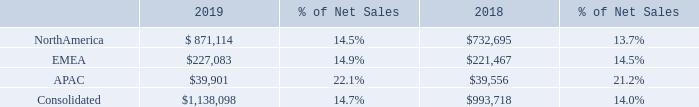Gross Profit. Gross profit increased 15%, or $144.4 million, in 2019 compared to 2018, with gross margin increasing approximately 70 basis points to 14.7% of net sales. Our gross profit and gross profit as a percent of net sales by operating segment for 2019 and 2018 were as follows (dollars in thousands):
North America’s gross profit in 2019 increased 19% compared to 2018, and as a percentage of net sales, gross margin increased by approximately 80 basis points year over year. The year over year net increase in gross margin was primarily attributable to the following:
• A net increase in product margin, which includes partner funding and freight, of 30 basis points year over year. This increase was due primarily to improvements in hardware and software product margin partially as a result of improvements in core business margins on product net sales and also as a result of PCM.
• Services margin improvement year over year of 50 basis points was generated from increased vendor funding, cloud solution offerings and referral fees. In addition, there was a 21 basis point improvement in margins from Insight delivered services.
EMEA’s gross profit in 2019 increased 3% (increased 8% excluding the effects of fluctuating foreign currency exchange rates), compared to 2018. As a percentage of net sales, gross margin increased by approximately 40 basis points year over year.
APAC’s gross profit in 2019 increased 1% (increased 6% excluding the effects of fluctuating foreign currency exchange rates), compared to 2018, with gross margin increasing to 22.1% in 2019 from 21.2% in 2018. The improvement in gross margin for both EMEA and APAC in 2019 compared to 2018 was due primarily to changes in sales mix to higher margin products and services.
How much did Gross profit increased in 2019 compared to 2018? $144.4 million. How much did North America's Gross profit increased in 2019 compared to 2018? 19%. How much did EMEA's Gross profit increased in 2019 compared to 2018? 3%. What is the change in Net sales of North America between 2018 and 2019?
Answer scale should be: thousand. 871,114-732,695
Answer: 138419. What is the change in Net sales of EMEA between 2018 and 2019?
Answer scale should be: thousand. 227,083-221,467
Answer: 5616. What is the average Net sales of North America for 2018 and 2019?
Answer scale should be: thousand. (871,114+732,695) / 2
Answer: 801904.5. 